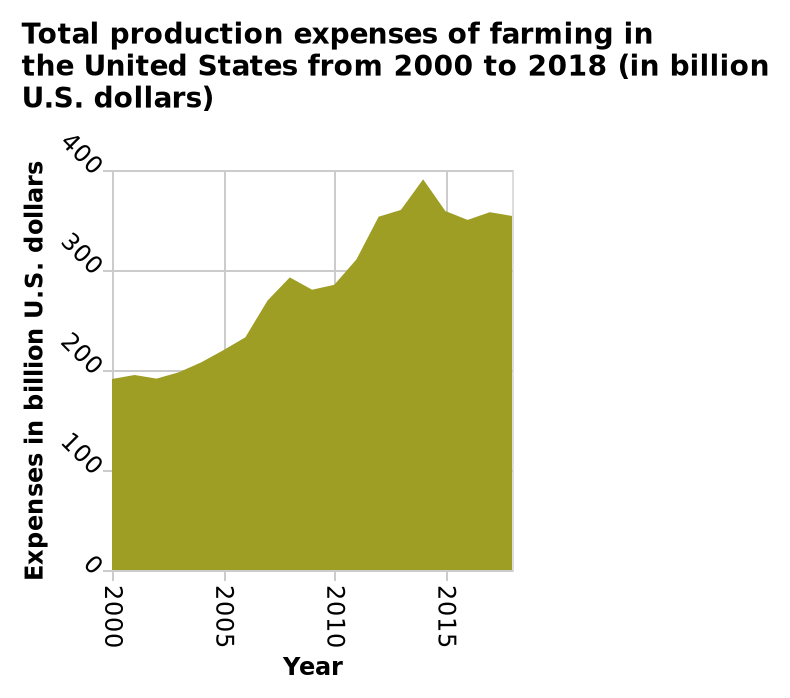<image>
What is the name of the area chart? Total production expenses of farming in the United States from 2000 to 2018 (in billion U.S. dollars). 